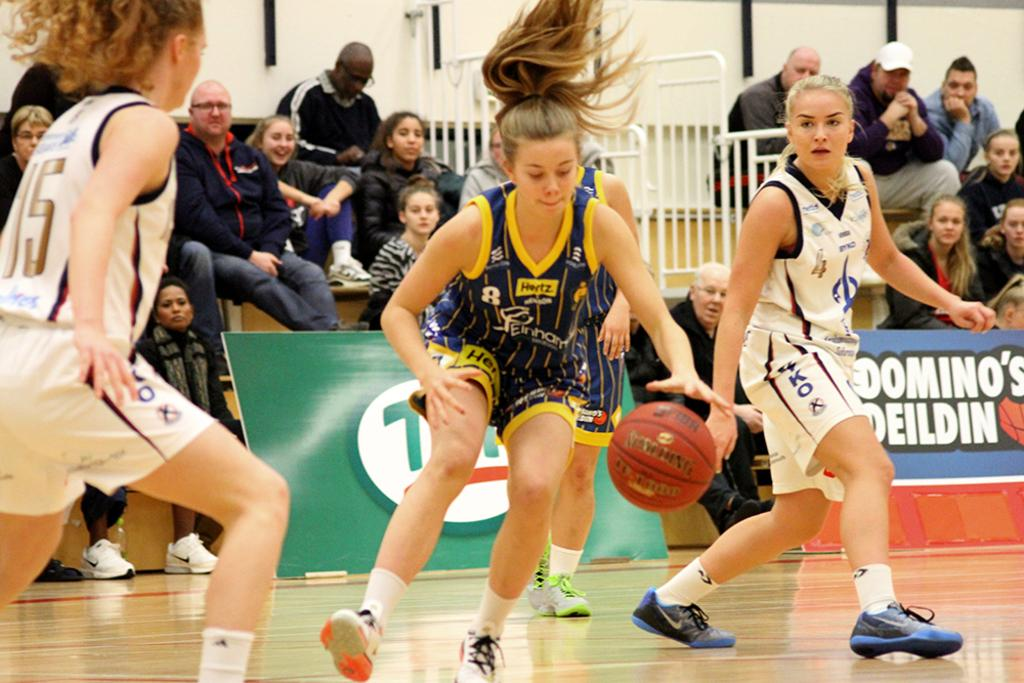<image>
Share a concise interpretation of the image provided. Several girls playing basketball in front of a crowd wear uniforms bearing the names of sponsors such as Hertz. 